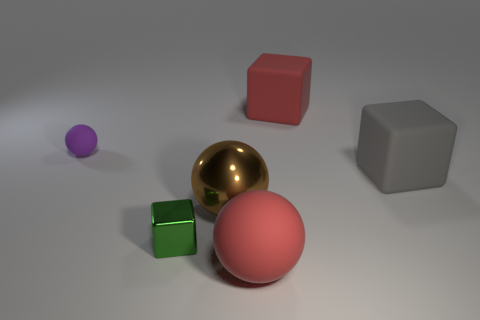Subtract all tiny balls. How many balls are left? 2 Add 1 large purple matte balls. How many objects exist? 7 Subtract all large balls. Subtract all large gray matte cubes. How many objects are left? 3 Add 6 large gray matte objects. How many large gray matte objects are left? 7 Add 3 large matte objects. How many large matte objects exist? 6 Subtract all red cubes. How many cubes are left? 2 Subtract 0 gray cylinders. How many objects are left? 6 Subtract 2 cubes. How many cubes are left? 1 Subtract all purple blocks. Subtract all red cylinders. How many blocks are left? 3 Subtract all purple cylinders. How many red spheres are left? 1 